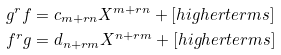Convert formula to latex. <formula><loc_0><loc_0><loc_500><loc_500>g ^ { r } f & = c _ { m + r n } X ^ { m + r n } + [ h i g h e r t e r m s ] \\ f ^ { r } g & = d _ { n + r m } X ^ { n + r m } + [ h i g h e r t e r m s ]</formula> 